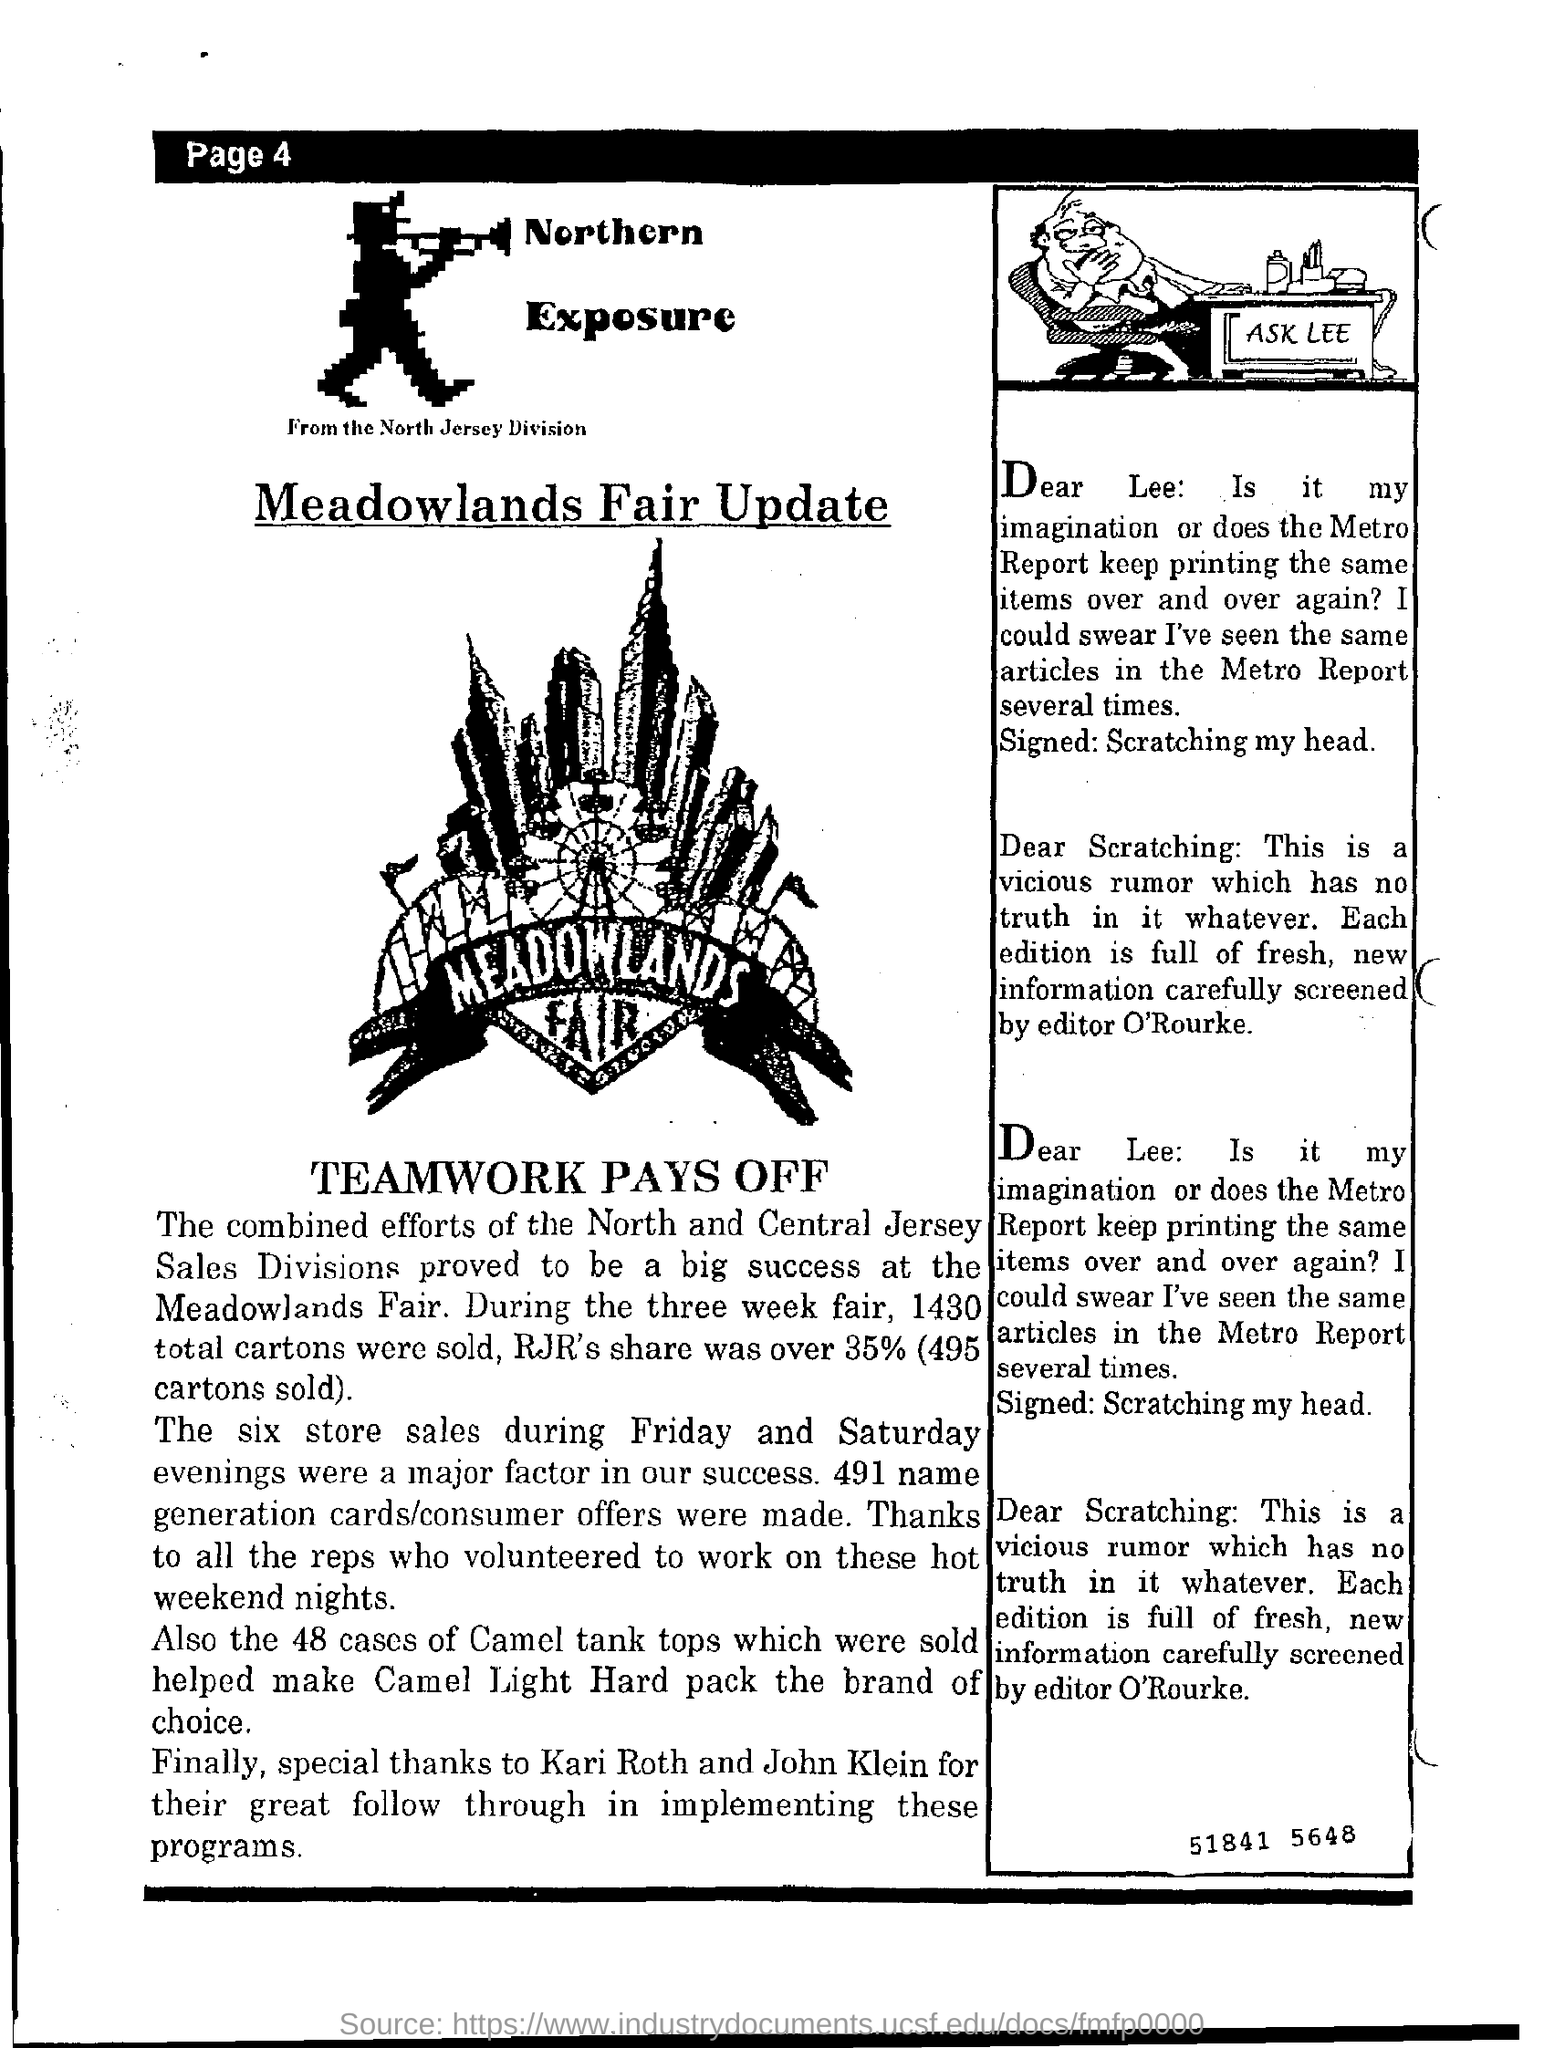What was RJR's share of sale during the three week fair?
Provide a succinct answer. Over 35% (495 cartons sold). Which was the brand of choice?
Provide a succinct answer. Camel light hard pack. Who is the editor?
Offer a terse response. O'Rourke. 